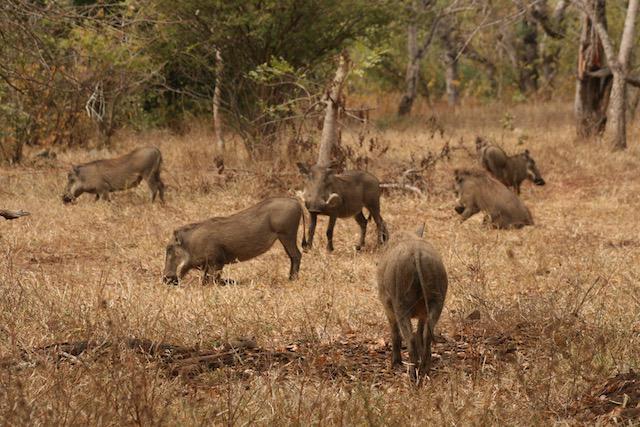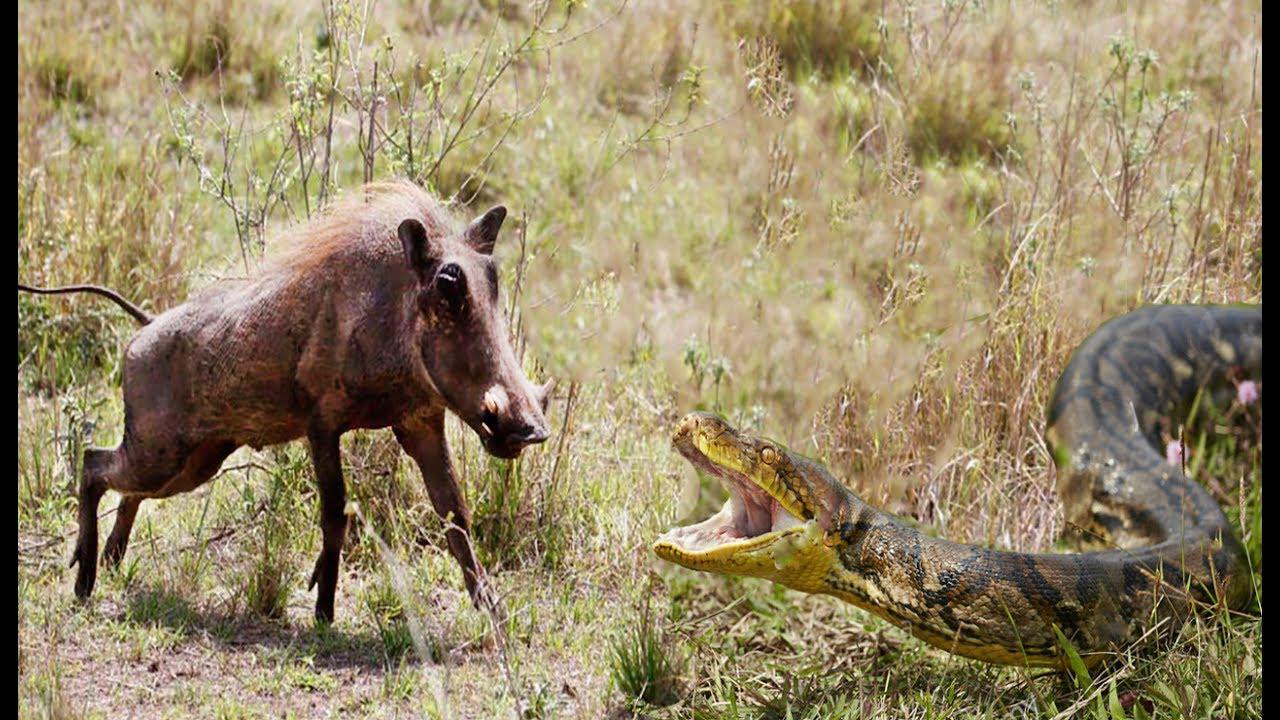The first image is the image on the left, the second image is the image on the right. Analyze the images presented: Is the assertion "there are exactly three boars in the image on the left" valid? Answer yes or no. No. 